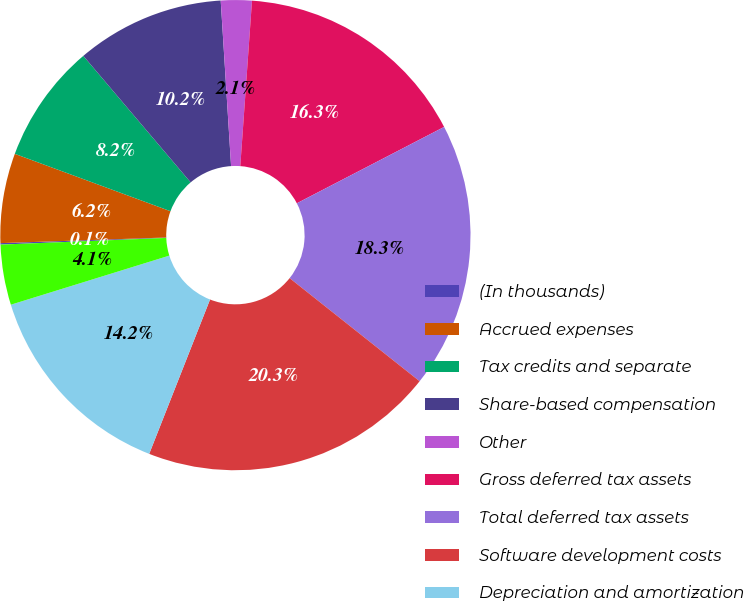Convert chart to OTSL. <chart><loc_0><loc_0><loc_500><loc_500><pie_chart><fcel>(In thousands)<fcel>Accrued expenses<fcel>Tax credits and separate<fcel>Share-based compensation<fcel>Other<fcel>Gross deferred tax assets<fcel>Total deferred tax assets<fcel>Software development costs<fcel>Depreciation and amortization<fcel>Prepaid expenses<nl><fcel>0.1%<fcel>6.16%<fcel>8.18%<fcel>10.2%<fcel>2.12%<fcel>16.26%<fcel>18.28%<fcel>20.3%<fcel>14.24%<fcel>4.14%<nl></chart> 